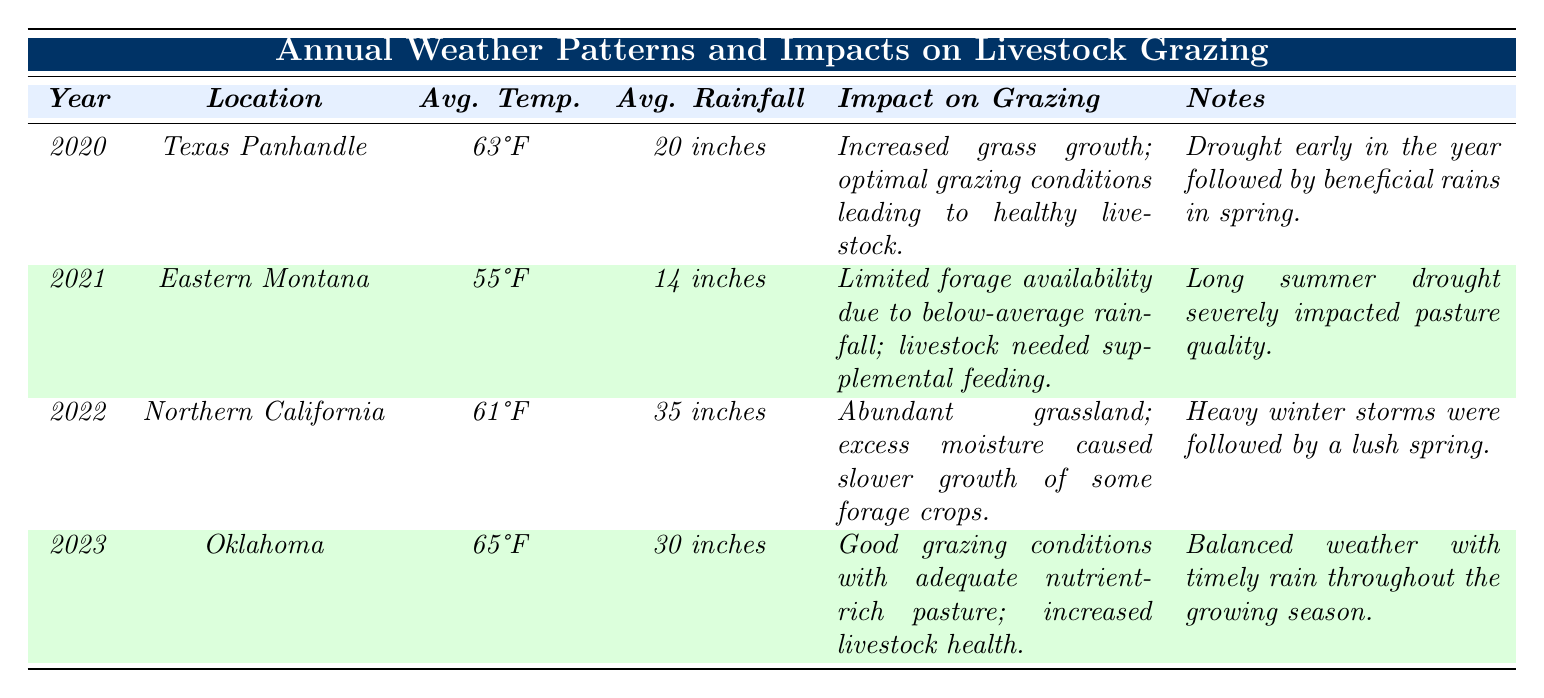What was the average rainfall in Texas Panhandle in 2020? The table shows that the average rainfall in the Texas Panhandle for the year 2020 is listed as 20 inches.
Answer: 20 inches Which year had the highest average temperature and what was it? By comparing the average temperatures, 2023 has the highest average temperature of 65°F, as reflected in the table.
Answer: 2023, 65°F Did Eastern Montana experience good grazing conditions in 2021? The impact on grazing for Eastern Montana in 2021 indicates limited forage availability and that livestock needed supplemental feeding, which suggests poor grazing conditions.
Answer: No What is the difference in average rainfall between 2021 and 2022? The rainfall for 2021 is 14 inches, and for 2022 it is 35 inches. The difference is 35 - 14 = 21 inches.
Answer: 21 inches Which location had the most rainfall in 2022 and how much was it? The table reveals that Northern California had the most rainfall in 2022, which totaled 35 inches.
Answer: Northern California, 35 inches According to the table, how many years had average temperatures below 60°F? The years with average temperatures below 60°F are 2021 (55°F) and 2022 (61°F). Only 2021 had a temperature below 60°F, so there is just one year.
Answer: 1 year What can be concluded about the impact on grazing in Oklahoma in 2023? The impact on grazing in 2023 shows good conditions with nutrient-rich pasture leading to increased livestock health, indicating a positively affected grazing situation.
Answer: Good conditions What trend is observed in rainfall amounts from 2020 to 2023? Looking at the data, the rainfall amounts are 20 inches (2020), 14 inches (2021), 35 inches (2022), and 30 inches (2023), which shows fluctuation without a clear upward or downward trend.
Answer: Fluctuating amounts Which year had the most favorable weather conditions for livestock grazing based on the table? Evaluating the impact on grazing, year 2023 in Oklahoma had good grazing conditions with adequate nutrient-rich pasture, suggesting it was the most favorable year.
Answer: 2023 What is the average temperature across all four years represented in the table? The average temperatures are 63°F (2020), 55°F (2021), 61°F (2022), and 65°F (2023). Calculating the average: (63 + 55 + 61 + 65) / 4 = 61.
Answer: 61°F 